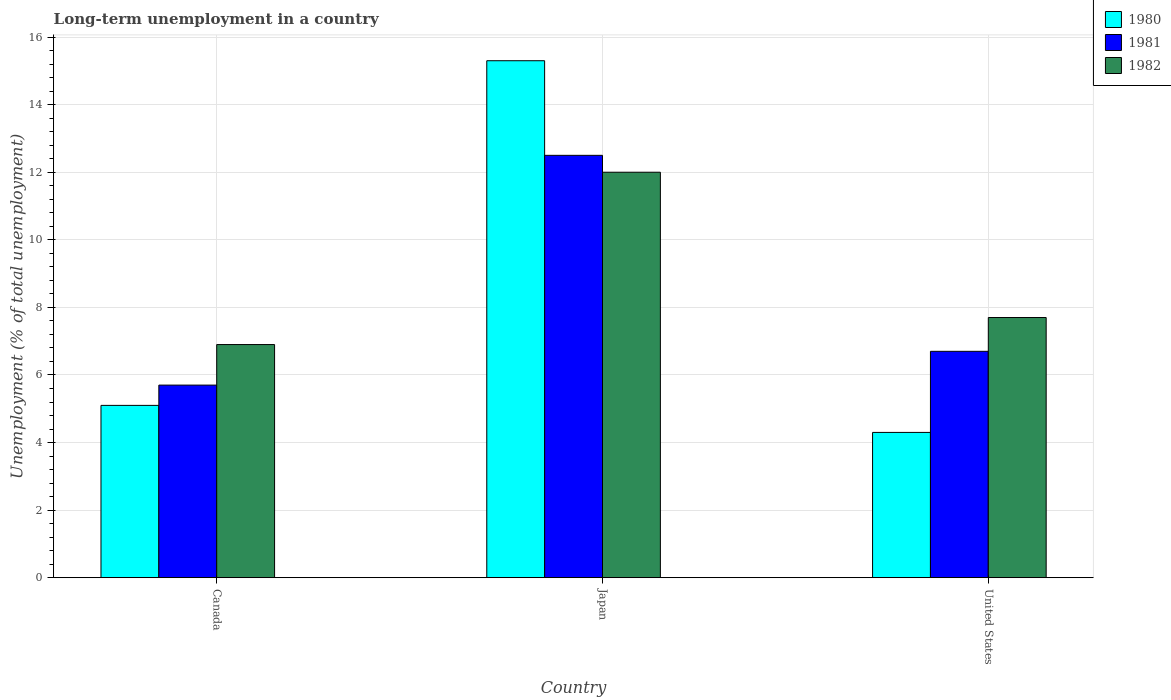How many different coloured bars are there?
Make the answer very short. 3. Are the number of bars per tick equal to the number of legend labels?
Your answer should be very brief. Yes. How many bars are there on the 1st tick from the left?
Your answer should be compact. 3. How many bars are there on the 2nd tick from the right?
Provide a short and direct response. 3. Across all countries, what is the maximum percentage of long-term unemployed population in 1980?
Your answer should be compact. 15.3. Across all countries, what is the minimum percentage of long-term unemployed population in 1981?
Your response must be concise. 5.7. In which country was the percentage of long-term unemployed population in 1981 maximum?
Provide a succinct answer. Japan. What is the total percentage of long-term unemployed population in 1982 in the graph?
Offer a very short reply. 26.6. What is the difference between the percentage of long-term unemployed population in 1981 in Japan and that in United States?
Your answer should be compact. 5.8. What is the difference between the percentage of long-term unemployed population in 1980 in United States and the percentage of long-term unemployed population in 1982 in Japan?
Give a very brief answer. -7.7. What is the average percentage of long-term unemployed population in 1981 per country?
Your response must be concise. 8.3. In how many countries, is the percentage of long-term unemployed population in 1981 greater than 9.2 %?
Offer a very short reply. 1. What is the ratio of the percentage of long-term unemployed population in 1981 in Japan to that in United States?
Keep it short and to the point. 1.87. Is the percentage of long-term unemployed population in 1982 in Japan less than that in United States?
Keep it short and to the point. No. Is the difference between the percentage of long-term unemployed population in 1982 in Canada and Japan greater than the difference between the percentage of long-term unemployed population in 1981 in Canada and Japan?
Offer a very short reply. Yes. What is the difference between the highest and the second highest percentage of long-term unemployed population in 1980?
Offer a terse response. -0.8. What is the difference between the highest and the lowest percentage of long-term unemployed population in 1980?
Offer a very short reply. 11. Is the sum of the percentage of long-term unemployed population in 1981 in Canada and Japan greater than the maximum percentage of long-term unemployed population in 1980 across all countries?
Your response must be concise. Yes. What does the 1st bar from the right in Canada represents?
Your response must be concise. 1982. Is it the case that in every country, the sum of the percentage of long-term unemployed population in 1982 and percentage of long-term unemployed population in 1980 is greater than the percentage of long-term unemployed population in 1981?
Your answer should be very brief. Yes. How many bars are there?
Your answer should be very brief. 9. How many countries are there in the graph?
Give a very brief answer. 3. Does the graph contain grids?
Offer a terse response. Yes. What is the title of the graph?
Provide a succinct answer. Long-term unemployment in a country. Does "1975" appear as one of the legend labels in the graph?
Provide a short and direct response. No. What is the label or title of the X-axis?
Provide a succinct answer. Country. What is the label or title of the Y-axis?
Offer a very short reply. Unemployment (% of total unemployment). What is the Unemployment (% of total unemployment) in 1980 in Canada?
Ensure brevity in your answer.  5.1. What is the Unemployment (% of total unemployment) of 1981 in Canada?
Your answer should be compact. 5.7. What is the Unemployment (% of total unemployment) in 1982 in Canada?
Your answer should be compact. 6.9. What is the Unemployment (% of total unemployment) of 1980 in Japan?
Provide a succinct answer. 15.3. What is the Unemployment (% of total unemployment) in 1981 in Japan?
Provide a short and direct response. 12.5. What is the Unemployment (% of total unemployment) in 1982 in Japan?
Ensure brevity in your answer.  12. What is the Unemployment (% of total unemployment) in 1980 in United States?
Keep it short and to the point. 4.3. What is the Unemployment (% of total unemployment) in 1981 in United States?
Offer a very short reply. 6.7. What is the Unemployment (% of total unemployment) in 1982 in United States?
Offer a terse response. 7.7. Across all countries, what is the maximum Unemployment (% of total unemployment) in 1980?
Provide a short and direct response. 15.3. Across all countries, what is the minimum Unemployment (% of total unemployment) of 1980?
Ensure brevity in your answer.  4.3. Across all countries, what is the minimum Unemployment (% of total unemployment) in 1981?
Your answer should be compact. 5.7. Across all countries, what is the minimum Unemployment (% of total unemployment) in 1982?
Your response must be concise. 6.9. What is the total Unemployment (% of total unemployment) in 1980 in the graph?
Keep it short and to the point. 24.7. What is the total Unemployment (% of total unemployment) of 1981 in the graph?
Offer a very short reply. 24.9. What is the total Unemployment (% of total unemployment) in 1982 in the graph?
Your response must be concise. 26.6. What is the difference between the Unemployment (% of total unemployment) of 1980 in Canada and that in Japan?
Keep it short and to the point. -10.2. What is the difference between the Unemployment (% of total unemployment) of 1981 in Canada and that in Japan?
Give a very brief answer. -6.8. What is the difference between the Unemployment (% of total unemployment) in 1982 in Canada and that in United States?
Provide a succinct answer. -0.8. What is the difference between the Unemployment (% of total unemployment) in 1981 in Canada and the Unemployment (% of total unemployment) in 1982 in Japan?
Your answer should be compact. -6.3. What is the difference between the Unemployment (% of total unemployment) of 1981 in Canada and the Unemployment (% of total unemployment) of 1982 in United States?
Keep it short and to the point. -2. What is the difference between the Unemployment (% of total unemployment) in 1980 in Japan and the Unemployment (% of total unemployment) in 1982 in United States?
Provide a succinct answer. 7.6. What is the difference between the Unemployment (% of total unemployment) of 1981 in Japan and the Unemployment (% of total unemployment) of 1982 in United States?
Make the answer very short. 4.8. What is the average Unemployment (% of total unemployment) in 1980 per country?
Give a very brief answer. 8.23. What is the average Unemployment (% of total unemployment) in 1981 per country?
Your answer should be compact. 8.3. What is the average Unemployment (% of total unemployment) in 1982 per country?
Ensure brevity in your answer.  8.87. What is the difference between the Unemployment (% of total unemployment) of 1980 and Unemployment (% of total unemployment) of 1982 in Canada?
Offer a very short reply. -1.8. What is the difference between the Unemployment (% of total unemployment) in 1980 and Unemployment (% of total unemployment) in 1981 in Japan?
Offer a very short reply. 2.8. What is the difference between the Unemployment (% of total unemployment) of 1980 and Unemployment (% of total unemployment) of 1982 in United States?
Your answer should be very brief. -3.4. What is the difference between the Unemployment (% of total unemployment) in 1981 and Unemployment (% of total unemployment) in 1982 in United States?
Your response must be concise. -1. What is the ratio of the Unemployment (% of total unemployment) of 1980 in Canada to that in Japan?
Ensure brevity in your answer.  0.33. What is the ratio of the Unemployment (% of total unemployment) in 1981 in Canada to that in Japan?
Keep it short and to the point. 0.46. What is the ratio of the Unemployment (% of total unemployment) of 1982 in Canada to that in Japan?
Keep it short and to the point. 0.57. What is the ratio of the Unemployment (% of total unemployment) of 1980 in Canada to that in United States?
Provide a succinct answer. 1.19. What is the ratio of the Unemployment (% of total unemployment) in 1981 in Canada to that in United States?
Your answer should be very brief. 0.85. What is the ratio of the Unemployment (% of total unemployment) in 1982 in Canada to that in United States?
Provide a short and direct response. 0.9. What is the ratio of the Unemployment (% of total unemployment) of 1980 in Japan to that in United States?
Make the answer very short. 3.56. What is the ratio of the Unemployment (% of total unemployment) in 1981 in Japan to that in United States?
Your answer should be very brief. 1.87. What is the ratio of the Unemployment (% of total unemployment) in 1982 in Japan to that in United States?
Offer a terse response. 1.56. What is the difference between the highest and the second highest Unemployment (% of total unemployment) in 1980?
Your response must be concise. 10.2. What is the difference between the highest and the second highest Unemployment (% of total unemployment) of 1981?
Provide a short and direct response. 5.8. What is the difference between the highest and the second highest Unemployment (% of total unemployment) of 1982?
Offer a terse response. 4.3. What is the difference between the highest and the lowest Unemployment (% of total unemployment) of 1981?
Make the answer very short. 6.8. What is the difference between the highest and the lowest Unemployment (% of total unemployment) of 1982?
Give a very brief answer. 5.1. 